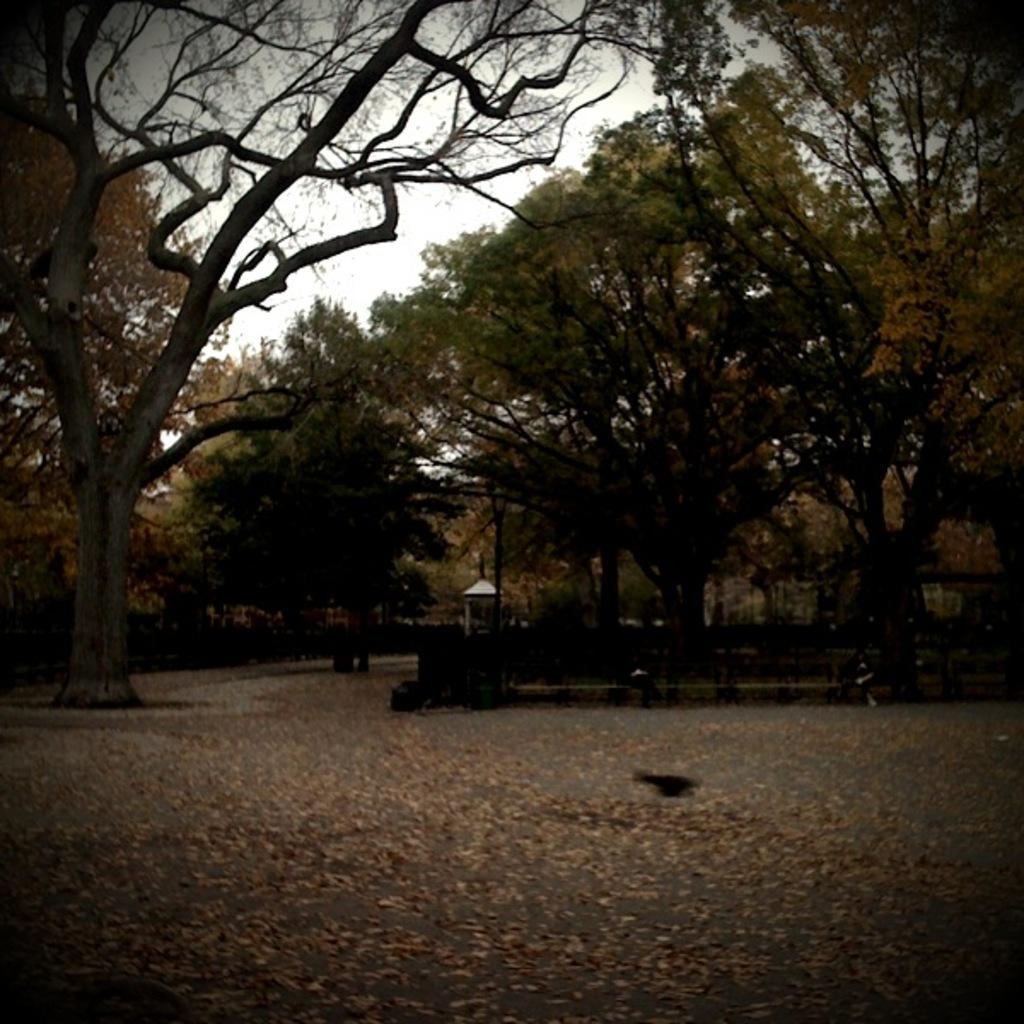What type of vegetation can be seen in the image? There are trees in the image. What is located at the bottom of the image? There are leaves at the bottom of the image. Where is the person sitting in the image? It appears that a person is sitting on a bench on the right side of the image. What is visible at the top of the image? The sky is visible at the top of the image. Can you hear the person's anger in the image? There is no sound or indication of anger in the image, as it is a still photograph. What is the person falling from in the image? There is no person falling in the image; it shows a person sitting on a bench. 